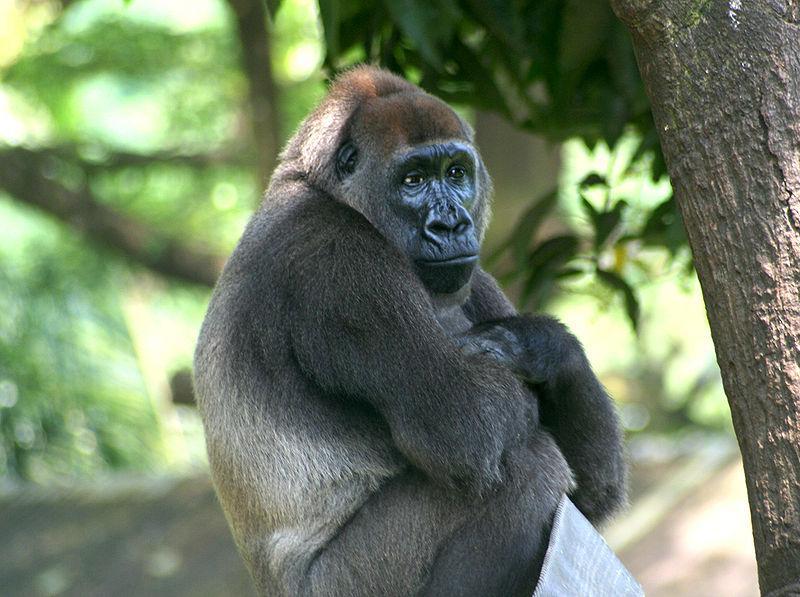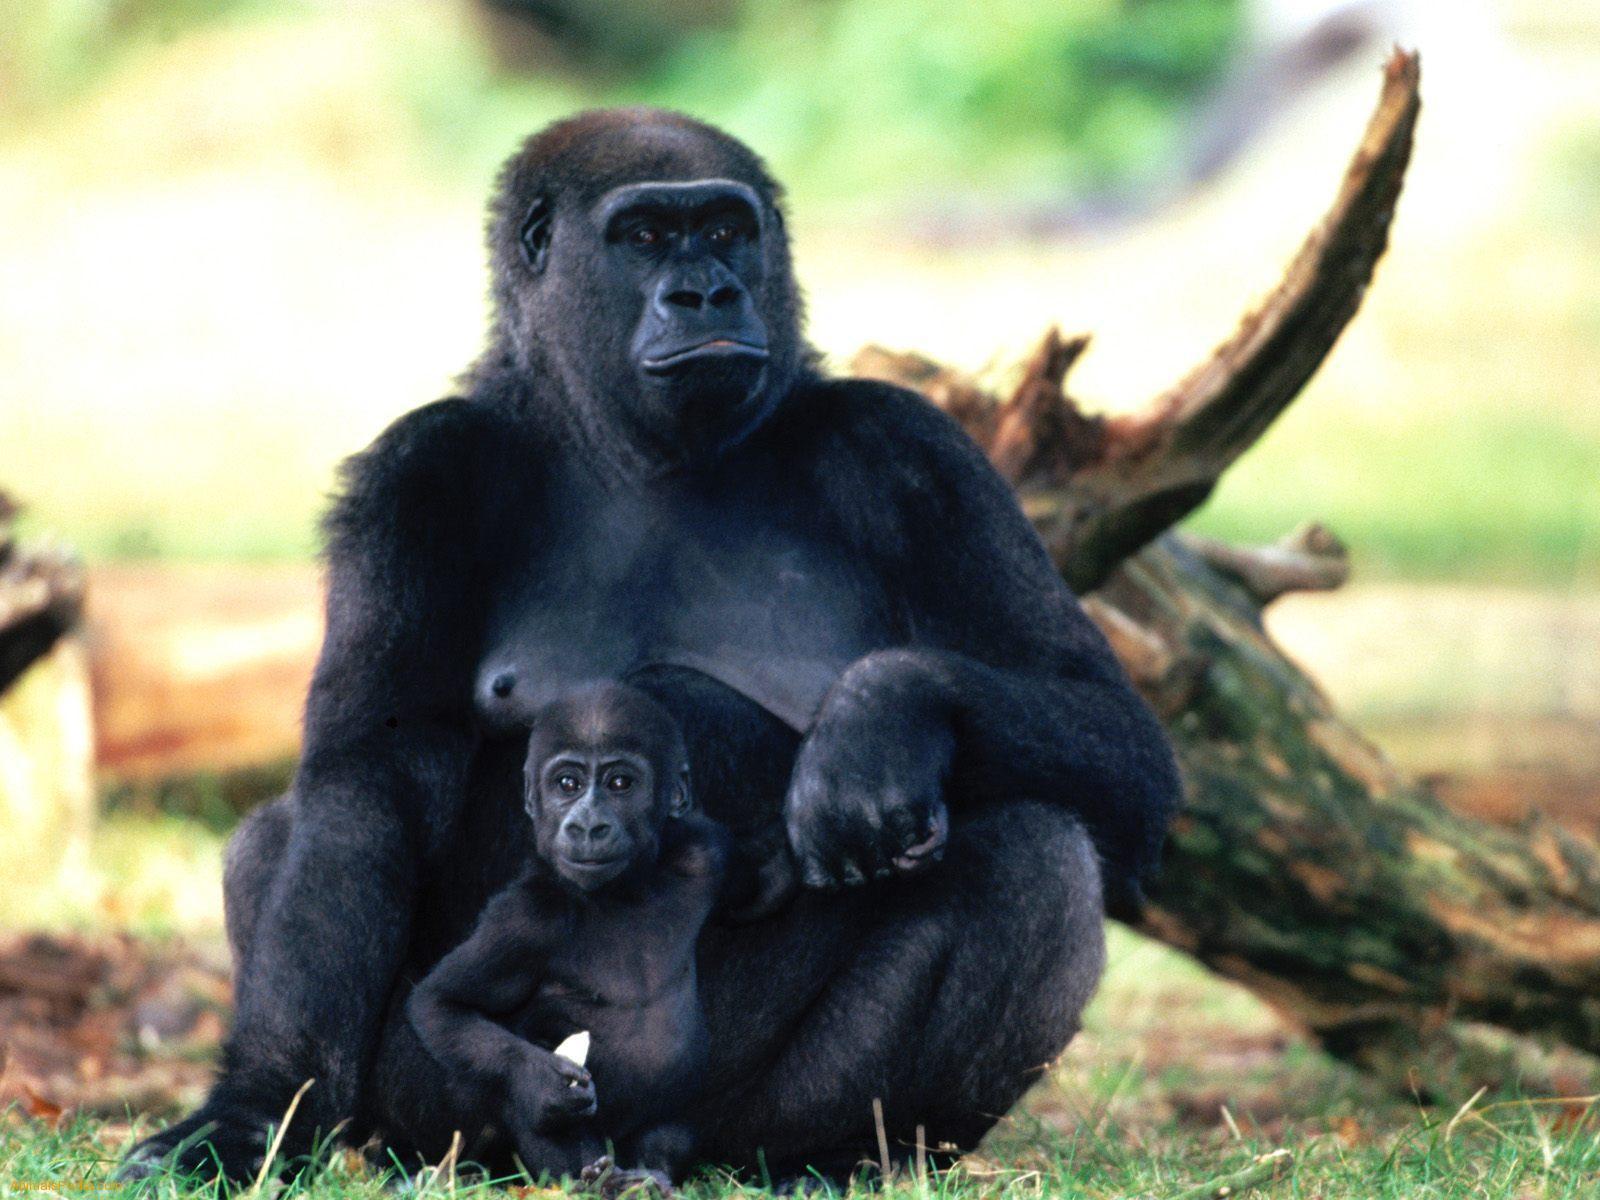The first image is the image on the left, the second image is the image on the right. Examine the images to the left and right. Is the description "One image includes a baby gorilla with its mother." accurate? Answer yes or no. Yes. 